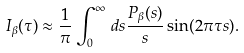<formula> <loc_0><loc_0><loc_500><loc_500>I _ { \beta } ( \tau ) \approx \frac { 1 } { \pi } \int _ { 0 } ^ { \infty } \, d s \frac { P _ { \beta } ( s ) } { s } \sin ( 2 \pi \tau s ) .</formula> 